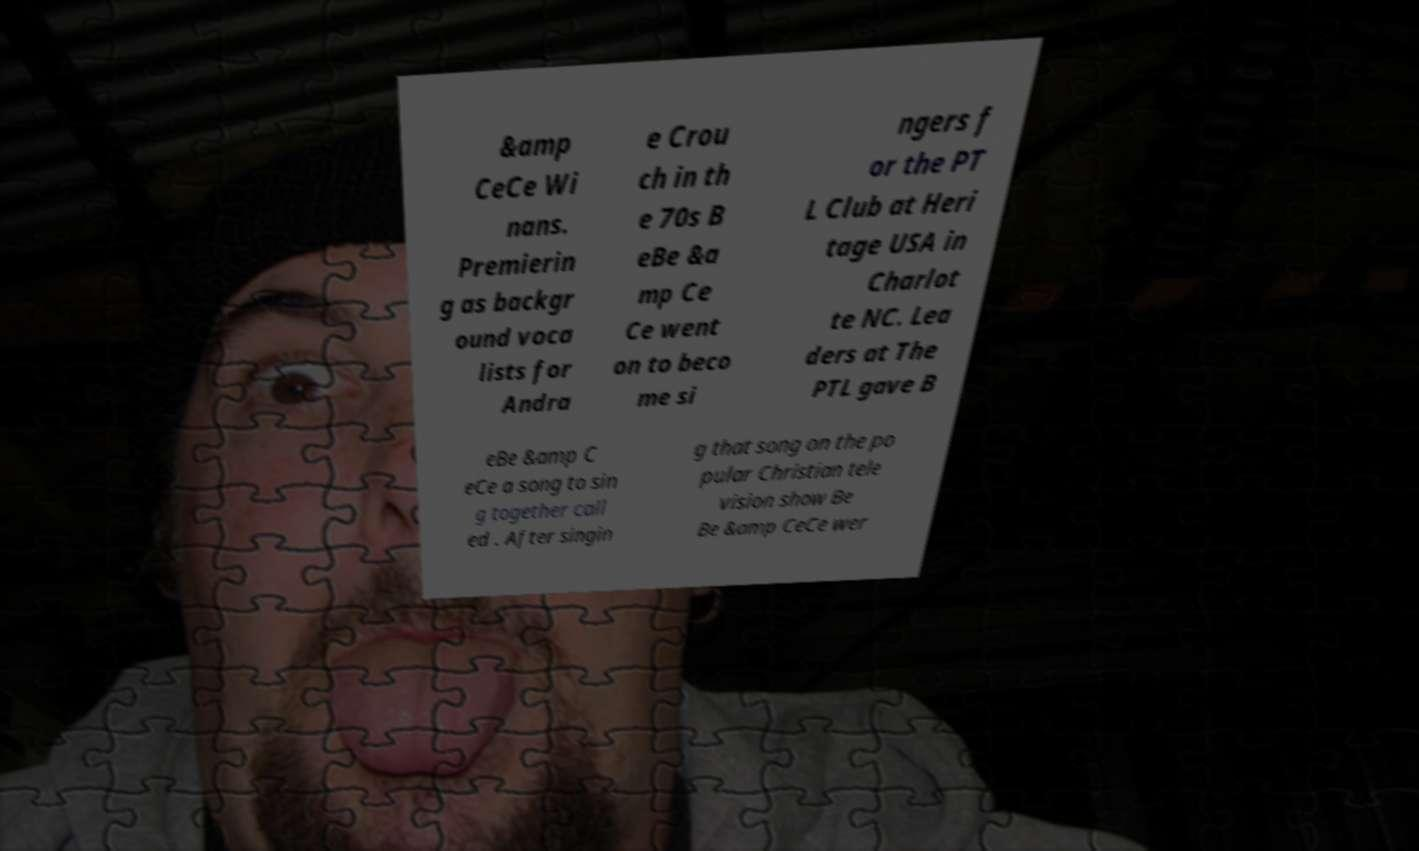Can you accurately transcribe the text from the provided image for me? &amp CeCe Wi nans. Premierin g as backgr ound voca lists for Andra e Crou ch in th e 70s B eBe &a mp Ce Ce went on to beco me si ngers f or the PT L Club at Heri tage USA in Charlot te NC. Lea ders at The PTL gave B eBe &amp C eCe a song to sin g together call ed . After singin g that song on the po pular Christian tele vision show Be Be &amp CeCe wer 